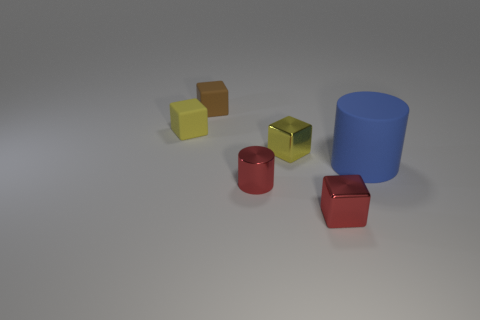Subtract all blue cubes. Subtract all purple balls. How many cubes are left? 4 Add 1 yellow matte things. How many objects exist? 7 Subtract all blocks. How many objects are left? 2 Add 2 tiny green matte cylinders. How many tiny green matte cylinders exist? 2 Subtract 0 gray cubes. How many objects are left? 6 Subtract all cyan matte cubes. Subtract all tiny matte cubes. How many objects are left? 4 Add 2 tiny red cylinders. How many tiny red cylinders are left? 3 